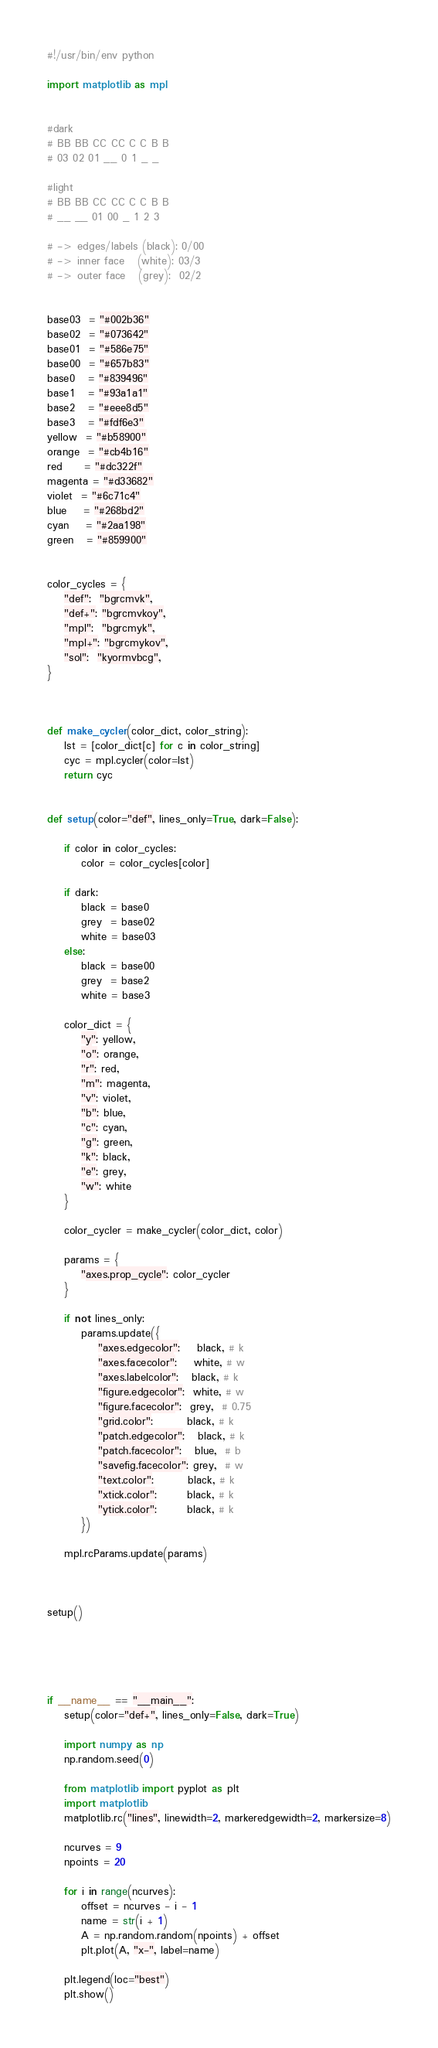Convert code to text. <code><loc_0><loc_0><loc_500><loc_500><_Python_>#!/usr/bin/env python

import matplotlib as mpl


#dark
# BB BB CC CC C C B B
# 03 02 01 __ 0 1 _ _

#light
# BB BB CC CC C C B B
# __ __ 01 00 _ 1 2 3

# -> edges/labels (black): 0/00
# -> inner face   (white): 03/3
# -> outer face   (grey):  02/2


base03  = "#002b36"
base02  = "#073642"
base01  = "#586e75"
base00  = "#657b83"
base0   = "#839496"
base1   = "#93a1a1"
base2   = "#eee8d5"
base3   = "#fdf6e3"
yellow  = "#b58900"
orange  = "#cb4b16"
red     = "#dc322f"
magenta = "#d33682"
violet  = "#6c71c4"
blue    = "#268bd2"
cyan    = "#2aa198"
green   = "#859900"


color_cycles = {
    "def":  "bgrcmvk",
    "def+": "bgrcmvkoy",
    "mpl":  "bgrcmyk",
    "mpl+": "bgrcmykov",
    "sol":  "kyormvbcg",
}



def make_cycler(color_dict, color_string):
    lst = [color_dict[c] for c in color_string]
    cyc = mpl.cycler(color=lst)
    return cyc


def setup(color="def", lines_only=True, dark=False):

    if color in color_cycles:
        color = color_cycles[color]

    if dark:
        black = base0
        grey  = base02
        white = base03
    else:
        black = base00
        grey  = base2
        white = base3

    color_dict = {
        "y": yellow,
        "o": orange,
        "r": red,
        "m": magenta,
        "v": violet,
        "b": blue,
        "c": cyan,
        "g": green,
        "k": black,
        "e": grey,
        "w": white
    }

    color_cycler = make_cycler(color_dict, color)

    params = {
        "axes.prop_cycle": color_cycler
    }

    if not lines_only:
        params.update({
            "axes.edgecolor":    black, # k
            "axes.facecolor":    white, # w
            "axes.labelcolor":   black, # k
            "figure.edgecolor":  white, # w
            "figure.facecolor":  grey,  # 0.75
            "grid.color":        black, # k
            "patch.edgecolor":   black, # k
            "patch.facecolor":   blue,  # b
            "savefig.facecolor": grey,  # w
            "text.color":        black, # k
            "xtick.color":       black, # k
            "ytick.color":       black, # k
        })

    mpl.rcParams.update(params)



setup()





if __name__ == "__main__":
    setup(color="def+", lines_only=False, dark=True)

    import numpy as np
    np.random.seed(0)

    from matplotlib import pyplot as plt
    import matplotlib
    matplotlib.rc("lines", linewidth=2, markeredgewidth=2, markersize=8)

    ncurves = 9
    npoints = 20

    for i in range(ncurves):
        offset = ncurves - i - 1
        name = str(i + 1)
        A = np.random.random(npoints) + offset
        plt.plot(A, "x-", label=name)

    plt.legend(loc="best")
    plt.show()



</code> 